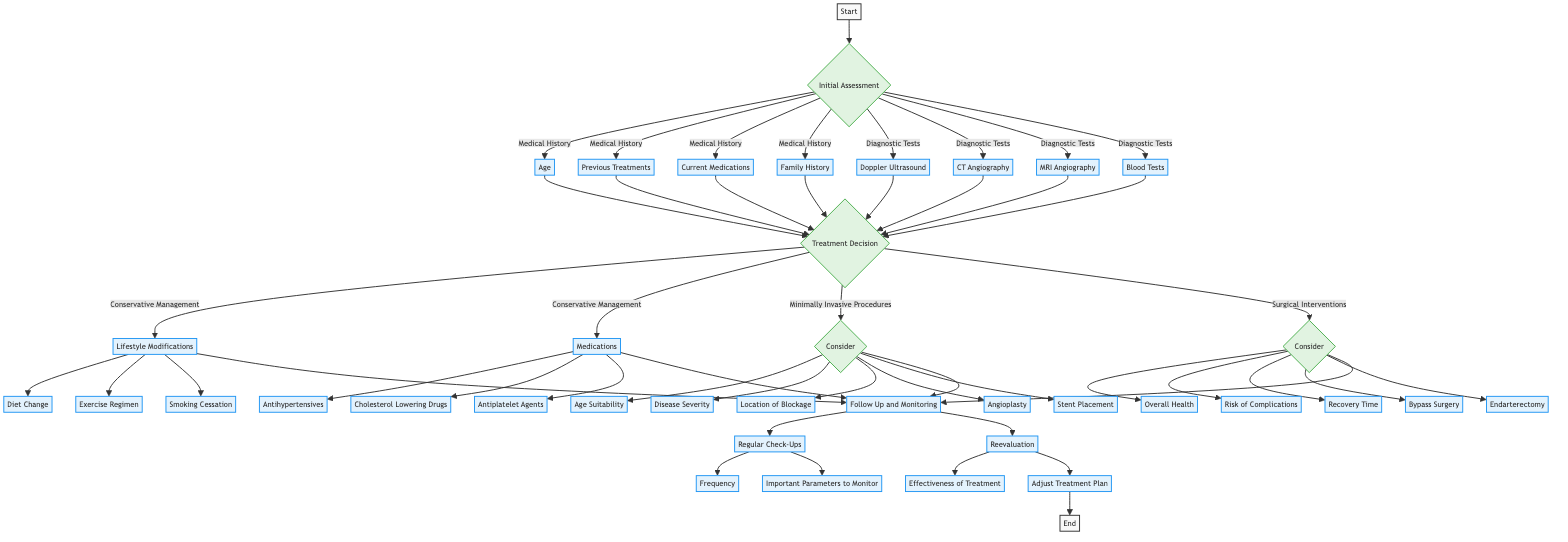What is the starting point of the diagram? The starting point of the diagram is indicated by the node labeled "Start," which is the initial node before the assessment process begins.
Answer: Start How many diagnostic tests are listed in the initial assessment? The node for Diagnostic Tests leads to four individual tests: Doppler Ultrasound, CT Angiography, MRI Angiography, and Blood Tests. Therefore, there are four diagnostic tests listed.
Answer: 4 What are the three options under surgical interventions? Under Surgical Interventions, the options listed are Bypass Surgery, Endarterectomy, and the decision node for considerations leads to them only.
Answer: Bypass Surgery, Endarterectomy What considerations must be evaluated before performing minimally invasive procedures? The considerations before minimally invasive procedures include Age Suitability, Disease Severity, and Location of Blockage as outlined in that decision segment.
Answer: Age Suitability, Disease Severity, Location of Blockage What is the final step in the decision pathway? The final step in the decision pathway is represented by the node "End," which signifies the conclusion of the treatment decision process.
Answer: End What leads to the follow-up and monitoring section? The path leading to the Follow Up and Monitoring section comes from all treatment options: Conservative Management, Minimally Invasive Procedures, and Surgical Interventions.
Answer: Follow Up and Monitoring Which medication options are available under conservative management? The medication options listed under Conservative Management are Antihypertensives, Cholesterol Lowering Drugs, and Antiplatelet Agents, indicating the various therapies available in this category.
Answer: Antihypertensives, Cholesterol Lowering Drugs, Antiplatelet Agents How do you initiate the treatment decision process? The treatment decision process is initiated after completing the Initial Assessment, which incorporates Medical History and Diagnostic Tests, leading to decision-making about treatment options.
Answer: Treatment Decision What type of modifications are included in conservative management? The types of modifications included in Conservative Management are Lifestyle Modifications such as Diet Change, Exercise Regimen, and Smoking Cessation, concerning the patient's health improvement.
Answer: Lifestyle Modifications 